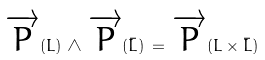<formula> <loc_0><loc_0><loc_500><loc_500>\overrightarrow { P } ( L ) \, \wedge \, \overrightarrow { P } ( \bar { L } ) \, = \, \overrightarrow { P } ( L \times \bar { L } )</formula> 